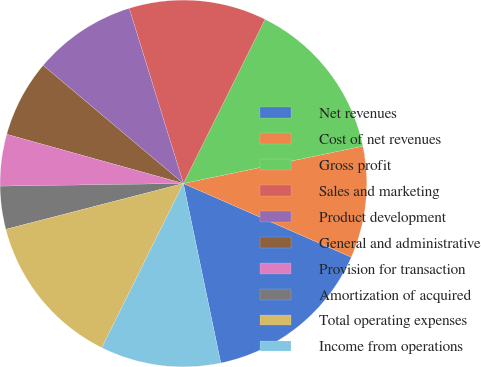Convert chart. <chart><loc_0><loc_0><loc_500><loc_500><pie_chart><fcel>Net revenues<fcel>Cost of net revenues<fcel>Gross profit<fcel>Sales and marketing<fcel>Product development<fcel>General and administrative<fcel>Provision for transaction<fcel>Amortization of acquired<fcel>Total operating expenses<fcel>Income from operations<nl><fcel>15.15%<fcel>9.85%<fcel>14.39%<fcel>12.12%<fcel>9.09%<fcel>6.82%<fcel>4.55%<fcel>3.79%<fcel>13.64%<fcel>10.61%<nl></chart> 